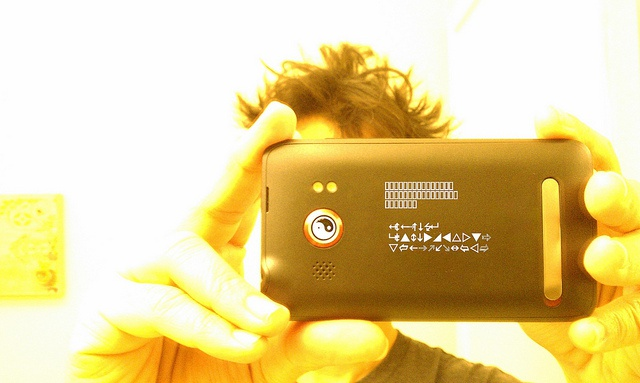Describe the objects in this image and their specific colors. I can see people in white, ivory, gold, orange, and yellow tones and cell phone in white, olive, orange, and gold tones in this image. 